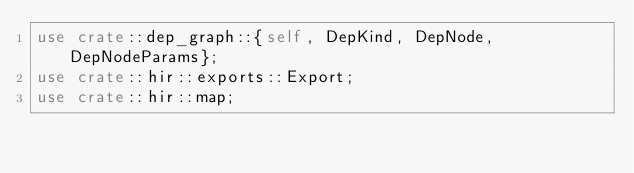<code> <loc_0><loc_0><loc_500><loc_500><_Rust_>use crate::dep_graph::{self, DepKind, DepNode, DepNodeParams};
use crate::hir::exports::Export;
use crate::hir::map;</code> 